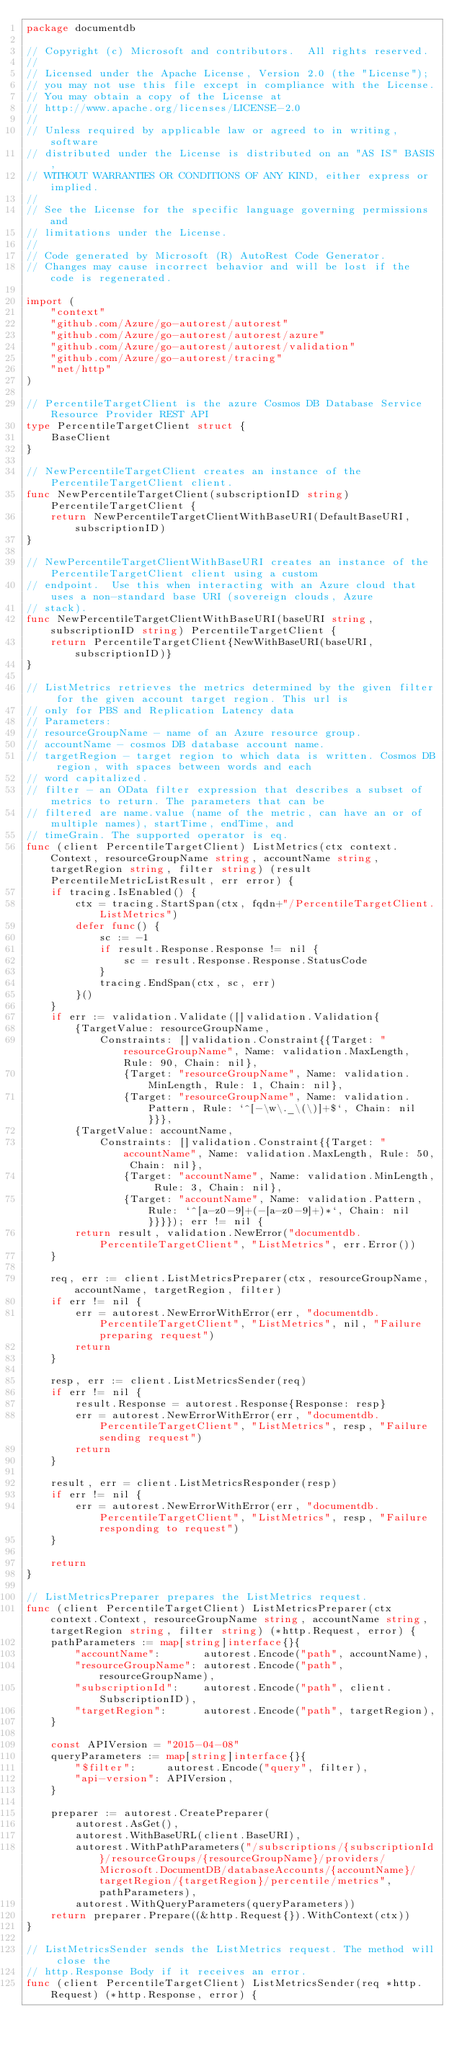<code> <loc_0><loc_0><loc_500><loc_500><_Go_>package documentdb

// Copyright (c) Microsoft and contributors.  All rights reserved.
//
// Licensed under the Apache License, Version 2.0 (the "License");
// you may not use this file except in compliance with the License.
// You may obtain a copy of the License at
// http://www.apache.org/licenses/LICENSE-2.0
//
// Unless required by applicable law or agreed to in writing, software
// distributed under the License is distributed on an "AS IS" BASIS,
// WITHOUT WARRANTIES OR CONDITIONS OF ANY KIND, either express or implied.
//
// See the License for the specific language governing permissions and
// limitations under the License.
//
// Code generated by Microsoft (R) AutoRest Code Generator.
// Changes may cause incorrect behavior and will be lost if the code is regenerated.

import (
	"context"
	"github.com/Azure/go-autorest/autorest"
	"github.com/Azure/go-autorest/autorest/azure"
	"github.com/Azure/go-autorest/autorest/validation"
	"github.com/Azure/go-autorest/tracing"
	"net/http"
)

// PercentileTargetClient is the azure Cosmos DB Database Service Resource Provider REST API
type PercentileTargetClient struct {
	BaseClient
}

// NewPercentileTargetClient creates an instance of the PercentileTargetClient client.
func NewPercentileTargetClient(subscriptionID string) PercentileTargetClient {
	return NewPercentileTargetClientWithBaseURI(DefaultBaseURI, subscriptionID)
}

// NewPercentileTargetClientWithBaseURI creates an instance of the PercentileTargetClient client using a custom
// endpoint.  Use this when interacting with an Azure cloud that uses a non-standard base URI (sovereign clouds, Azure
// stack).
func NewPercentileTargetClientWithBaseURI(baseURI string, subscriptionID string) PercentileTargetClient {
	return PercentileTargetClient{NewWithBaseURI(baseURI, subscriptionID)}
}

// ListMetrics retrieves the metrics determined by the given filter for the given account target region. This url is
// only for PBS and Replication Latency data
// Parameters:
// resourceGroupName - name of an Azure resource group.
// accountName - cosmos DB database account name.
// targetRegion - target region to which data is written. Cosmos DB region, with spaces between words and each
// word capitalized.
// filter - an OData filter expression that describes a subset of metrics to return. The parameters that can be
// filtered are name.value (name of the metric, can have an or of multiple names), startTime, endTime, and
// timeGrain. The supported operator is eq.
func (client PercentileTargetClient) ListMetrics(ctx context.Context, resourceGroupName string, accountName string, targetRegion string, filter string) (result PercentileMetricListResult, err error) {
	if tracing.IsEnabled() {
		ctx = tracing.StartSpan(ctx, fqdn+"/PercentileTargetClient.ListMetrics")
		defer func() {
			sc := -1
			if result.Response.Response != nil {
				sc = result.Response.Response.StatusCode
			}
			tracing.EndSpan(ctx, sc, err)
		}()
	}
	if err := validation.Validate([]validation.Validation{
		{TargetValue: resourceGroupName,
			Constraints: []validation.Constraint{{Target: "resourceGroupName", Name: validation.MaxLength, Rule: 90, Chain: nil},
				{Target: "resourceGroupName", Name: validation.MinLength, Rule: 1, Chain: nil},
				{Target: "resourceGroupName", Name: validation.Pattern, Rule: `^[-\w\._\(\)]+$`, Chain: nil}}},
		{TargetValue: accountName,
			Constraints: []validation.Constraint{{Target: "accountName", Name: validation.MaxLength, Rule: 50, Chain: nil},
				{Target: "accountName", Name: validation.MinLength, Rule: 3, Chain: nil},
				{Target: "accountName", Name: validation.Pattern, Rule: `^[a-z0-9]+(-[a-z0-9]+)*`, Chain: nil}}}}); err != nil {
		return result, validation.NewError("documentdb.PercentileTargetClient", "ListMetrics", err.Error())
	}

	req, err := client.ListMetricsPreparer(ctx, resourceGroupName, accountName, targetRegion, filter)
	if err != nil {
		err = autorest.NewErrorWithError(err, "documentdb.PercentileTargetClient", "ListMetrics", nil, "Failure preparing request")
		return
	}

	resp, err := client.ListMetricsSender(req)
	if err != nil {
		result.Response = autorest.Response{Response: resp}
		err = autorest.NewErrorWithError(err, "documentdb.PercentileTargetClient", "ListMetrics", resp, "Failure sending request")
		return
	}

	result, err = client.ListMetricsResponder(resp)
	if err != nil {
		err = autorest.NewErrorWithError(err, "documentdb.PercentileTargetClient", "ListMetrics", resp, "Failure responding to request")
	}

	return
}

// ListMetricsPreparer prepares the ListMetrics request.
func (client PercentileTargetClient) ListMetricsPreparer(ctx context.Context, resourceGroupName string, accountName string, targetRegion string, filter string) (*http.Request, error) {
	pathParameters := map[string]interface{}{
		"accountName":       autorest.Encode("path", accountName),
		"resourceGroupName": autorest.Encode("path", resourceGroupName),
		"subscriptionId":    autorest.Encode("path", client.SubscriptionID),
		"targetRegion":      autorest.Encode("path", targetRegion),
	}

	const APIVersion = "2015-04-08"
	queryParameters := map[string]interface{}{
		"$filter":     autorest.Encode("query", filter),
		"api-version": APIVersion,
	}

	preparer := autorest.CreatePreparer(
		autorest.AsGet(),
		autorest.WithBaseURL(client.BaseURI),
		autorest.WithPathParameters("/subscriptions/{subscriptionId}/resourceGroups/{resourceGroupName}/providers/Microsoft.DocumentDB/databaseAccounts/{accountName}/targetRegion/{targetRegion}/percentile/metrics", pathParameters),
		autorest.WithQueryParameters(queryParameters))
	return preparer.Prepare((&http.Request{}).WithContext(ctx))
}

// ListMetricsSender sends the ListMetrics request. The method will close the
// http.Response Body if it receives an error.
func (client PercentileTargetClient) ListMetricsSender(req *http.Request) (*http.Response, error) {</code> 